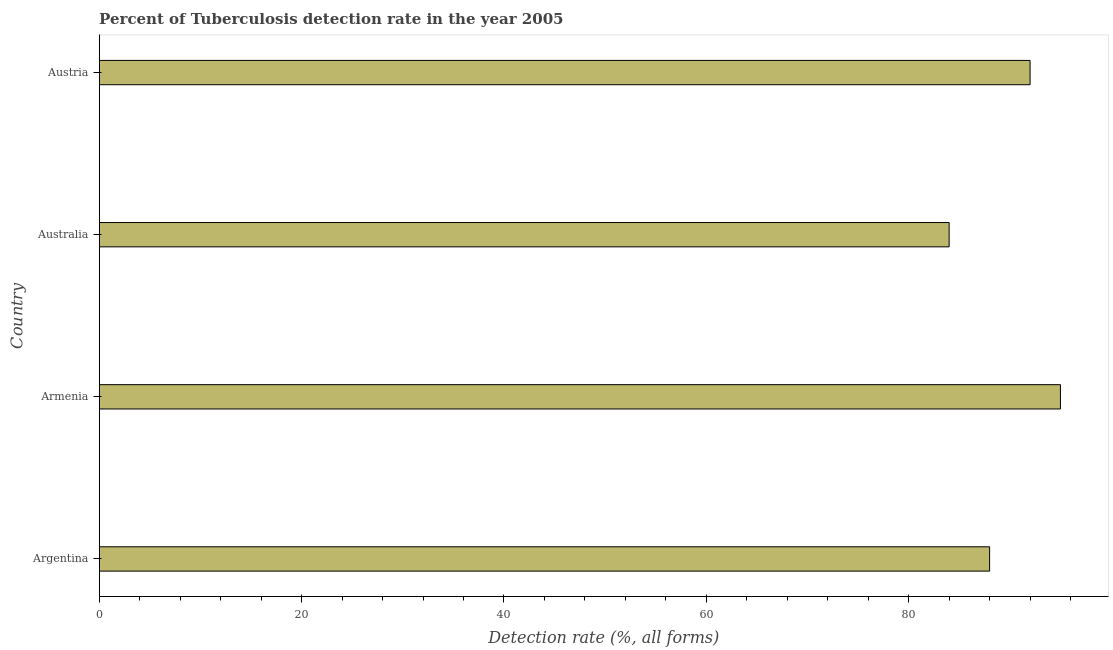Does the graph contain any zero values?
Offer a very short reply. No. What is the title of the graph?
Ensure brevity in your answer.  Percent of Tuberculosis detection rate in the year 2005. What is the label or title of the X-axis?
Provide a short and direct response. Detection rate (%, all forms). What is the detection rate of tuberculosis in Austria?
Give a very brief answer. 92. Across all countries, what is the maximum detection rate of tuberculosis?
Your answer should be very brief. 95. Across all countries, what is the minimum detection rate of tuberculosis?
Provide a succinct answer. 84. In which country was the detection rate of tuberculosis maximum?
Offer a terse response. Armenia. In which country was the detection rate of tuberculosis minimum?
Provide a succinct answer. Australia. What is the sum of the detection rate of tuberculosis?
Keep it short and to the point. 359. What is the average detection rate of tuberculosis per country?
Your answer should be very brief. 89. What is the median detection rate of tuberculosis?
Your response must be concise. 90. In how many countries, is the detection rate of tuberculosis greater than 44 %?
Your answer should be very brief. 4. What is the ratio of the detection rate of tuberculosis in Argentina to that in Australia?
Provide a succinct answer. 1.05. Is the detection rate of tuberculosis in Argentina less than that in Armenia?
Your answer should be compact. Yes. Is the difference between the detection rate of tuberculosis in Australia and Austria greater than the difference between any two countries?
Your answer should be very brief. No. What is the difference between the highest and the second highest detection rate of tuberculosis?
Make the answer very short. 3. Is the sum of the detection rate of tuberculosis in Armenia and Austria greater than the maximum detection rate of tuberculosis across all countries?
Your response must be concise. Yes. How many bars are there?
Offer a very short reply. 4. Are all the bars in the graph horizontal?
Provide a succinct answer. Yes. How many countries are there in the graph?
Offer a terse response. 4. What is the difference between two consecutive major ticks on the X-axis?
Your answer should be compact. 20. Are the values on the major ticks of X-axis written in scientific E-notation?
Provide a short and direct response. No. What is the Detection rate (%, all forms) of Austria?
Offer a very short reply. 92. What is the difference between the Detection rate (%, all forms) in Argentina and Armenia?
Make the answer very short. -7. What is the difference between the Detection rate (%, all forms) in Argentina and Australia?
Provide a succinct answer. 4. What is the difference between the Detection rate (%, all forms) in Australia and Austria?
Provide a succinct answer. -8. What is the ratio of the Detection rate (%, all forms) in Argentina to that in Armenia?
Give a very brief answer. 0.93. What is the ratio of the Detection rate (%, all forms) in Argentina to that in Australia?
Keep it short and to the point. 1.05. What is the ratio of the Detection rate (%, all forms) in Argentina to that in Austria?
Provide a succinct answer. 0.96. What is the ratio of the Detection rate (%, all forms) in Armenia to that in Australia?
Ensure brevity in your answer.  1.13. What is the ratio of the Detection rate (%, all forms) in Armenia to that in Austria?
Your response must be concise. 1.03. 